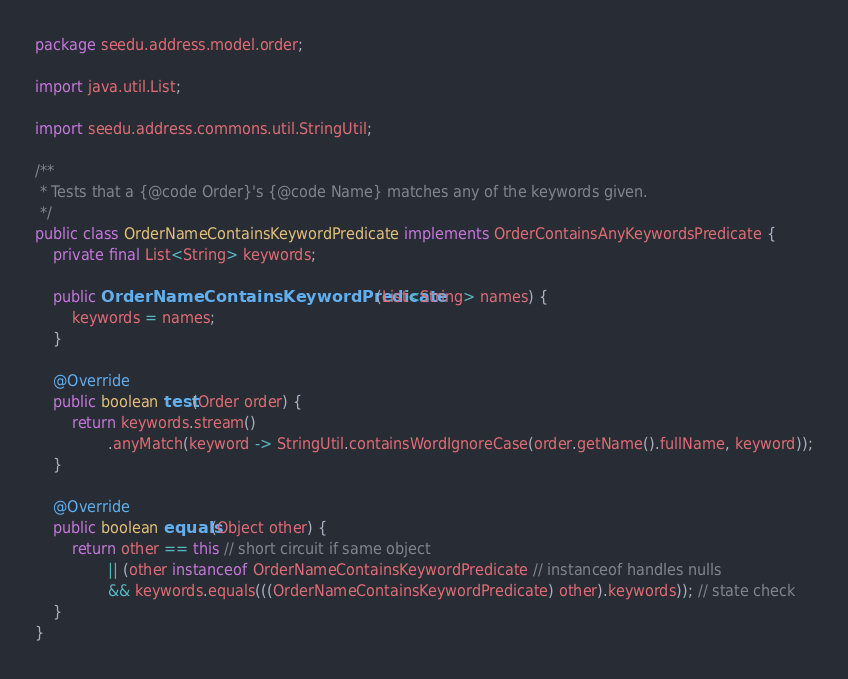Convert code to text. <code><loc_0><loc_0><loc_500><loc_500><_Java_>package seedu.address.model.order;

import java.util.List;

import seedu.address.commons.util.StringUtil;

/**
 * Tests that a {@code Order}'s {@code Name} matches any of the keywords given.
 */
public class OrderNameContainsKeywordPredicate implements OrderContainsAnyKeywordsPredicate {
    private final List<String> keywords;

    public OrderNameContainsKeywordPredicate(List<String> names) {
        keywords = names;
    }

    @Override
    public boolean test(Order order) {
        return keywords.stream()
                .anyMatch(keyword -> StringUtil.containsWordIgnoreCase(order.getName().fullName, keyword));
    }

    @Override
    public boolean equals(Object other) {
        return other == this // short circuit if same object
                || (other instanceof OrderNameContainsKeywordPredicate // instanceof handles nulls
                && keywords.equals(((OrderNameContainsKeywordPredicate) other).keywords)); // state check
    }
}
</code> 